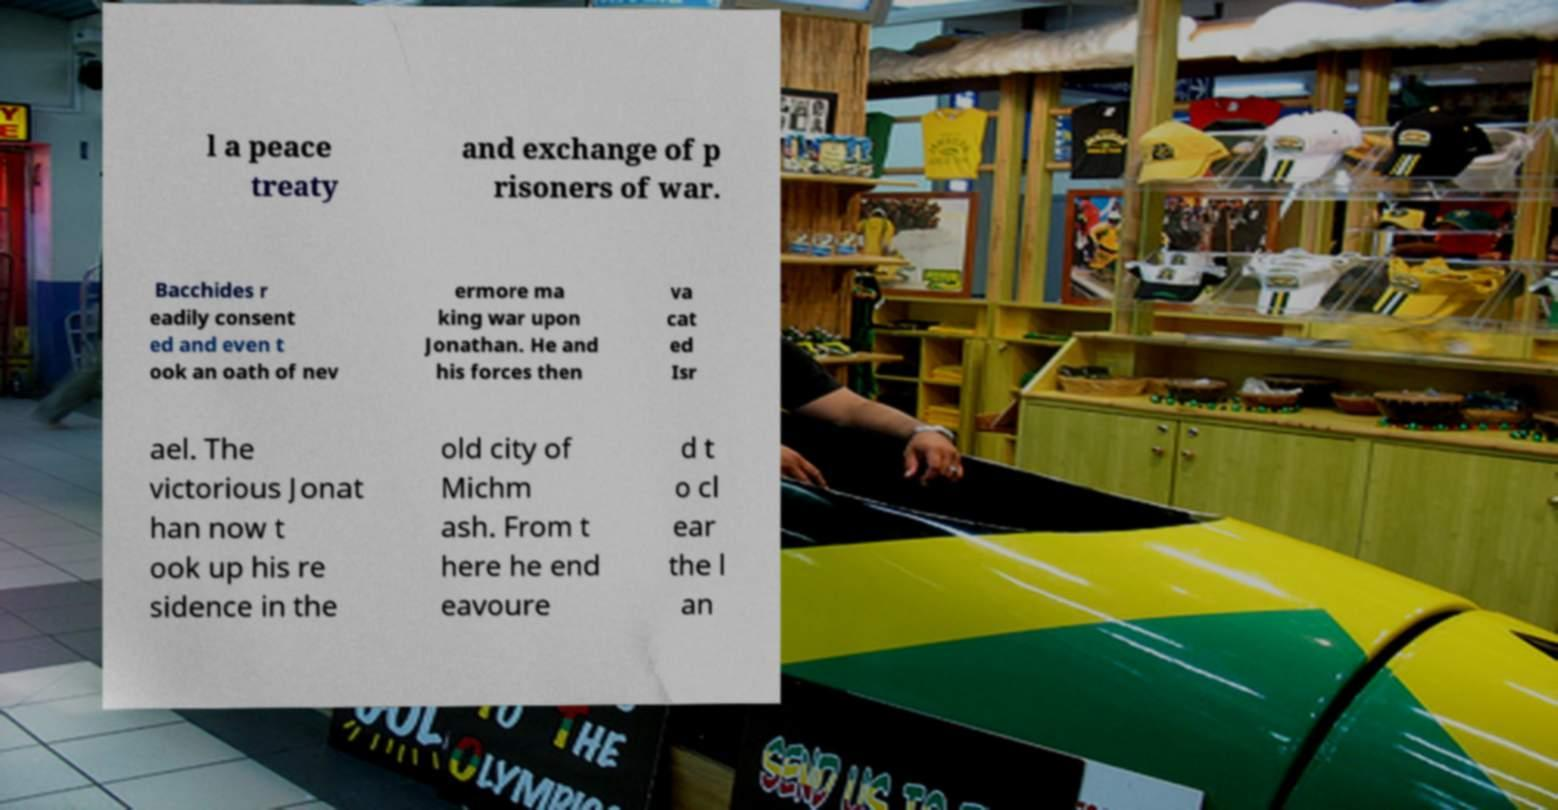I need the written content from this picture converted into text. Can you do that? l a peace treaty and exchange of p risoners of war. Bacchides r eadily consent ed and even t ook an oath of nev ermore ma king war upon Jonathan. He and his forces then va cat ed Isr ael. The victorious Jonat han now t ook up his re sidence in the old city of Michm ash. From t here he end eavoure d t o cl ear the l an 